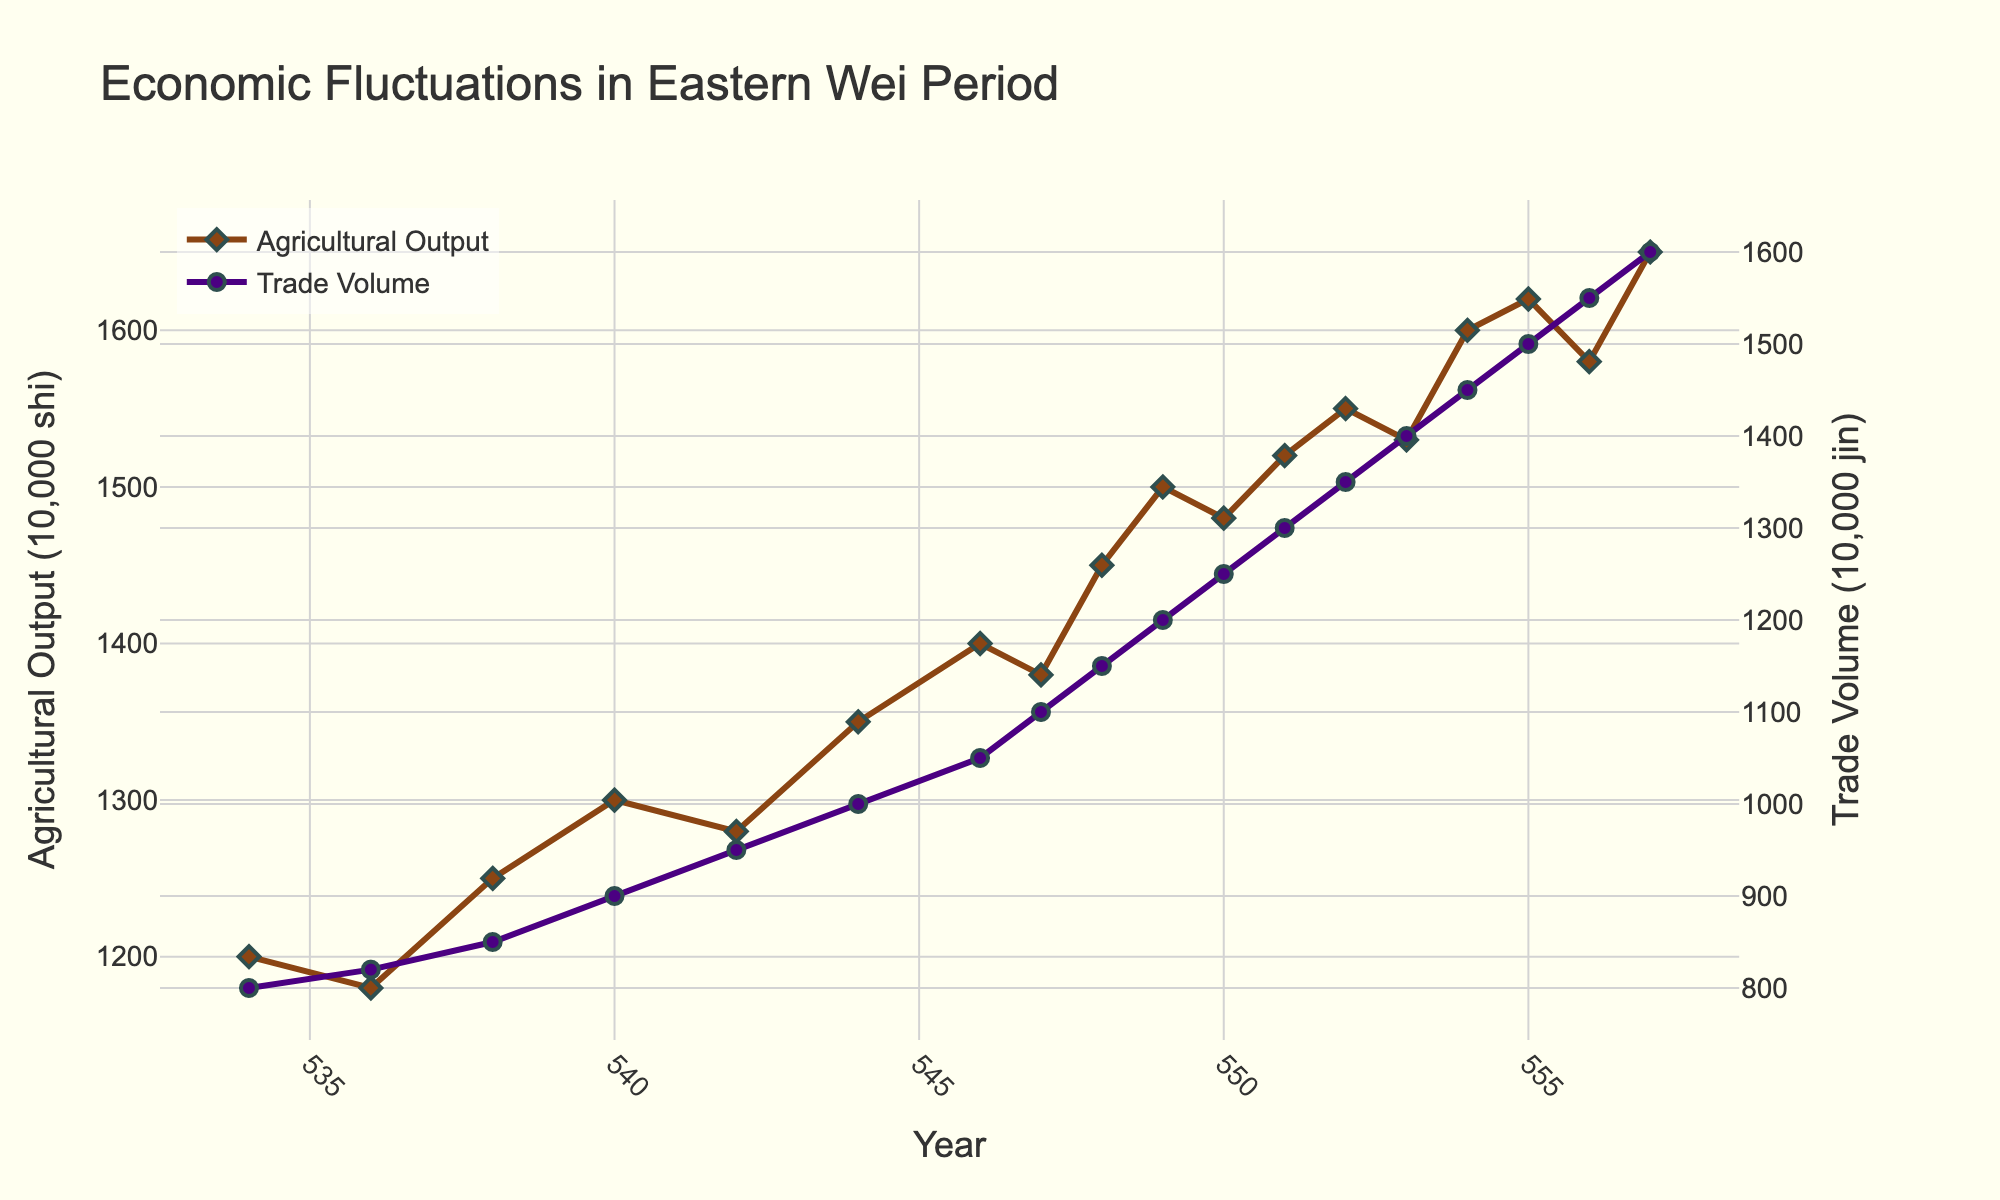What is the difference in Agricultural Output between the years 540 and 546? In 540, the Agricultural Output was 1300, and in 546 it was 1400. The difference is 1400 - 1300 = 100.
Answer: 100 Which year shows the highest Trade Volume? The highest Trade Volume is observed at 1600 in the year 557.
Answer: 557 How does the trade volume in 548 compare to 542? In 548, Trade Volume is 1150, and in 542 it is 950. The trade volume in 548 is higher by 1150 - 950 = 200.
Answer: 200 What is the average Agricultural Output across the years 544 to 550? The Agricultural Outputs for 544, 546, 547, 548, 549, and 550 are 1350, 1400, 1380, 1450, 1500, and 1480, respectively. Average is (1350 + 1400 + 1380 + 1450 + 1500 + 1480) / 6 = 1426.67.
Answer: 1426.67 Between which years is the largest increase in Trade Volume observed? The largest increase is observed between 536 (820) and 540 (900) with an increase of 80.
Answer: 536 to 540 What is the total Trade Volume from the years 550 to 555? Trade Volumes for 550, 551, 552, 553, 554, and 555 are 1250, 1300, 1350, 1400, 1450, and 1500, respectively. Total Trade Volume = 1250 + 1300 + 1350 + 1400 + 1450 + 1500 = 8250.
Answer: 8250 Does the Trade Volume ever decrease during the given years? The Trade Volume does not decrease in any year; it maintains a steady increase throughout.
Answer: No How many times does Agricultural Output exceed 1500 shi in a year? The Agricultural Output exceeds 1500 shi in the years 554, 555, 556, and 557. This happens 4 times.
Answer: 4 In which years do both Agricultural Output and Trade Volume peak? Both Agricultural Output and Trade Volume peak in the year 557, where Agricultural Output is 1650 and Trade Volume is 1600.
Answer: 557 Between the years 536 and 538, which metric shows greater relative increase, Agricultural Output or Trade Volume? Agricultural Output increased from 1180 to 1250, which is an increase of 70. Trade Volume increased by 30 from 820 to 850. Percentage-wise, Agricultural Output's relative increase is (70/1180)*100 ≈ 5.93%, and Trade Volume's relative increase is (30/820)*100 ≈ 3.66%. Therefore, Agricultural Output shows the greater relative increase.
Answer: Agricultural Output 